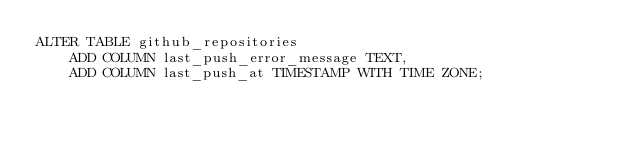Convert code to text. <code><loc_0><loc_0><loc_500><loc_500><_SQL_>ALTER TABLE github_repositories
    ADD COLUMN last_push_error_message TEXT,
    ADD COLUMN last_push_at TIMESTAMP WITH TIME ZONE;
</code> 